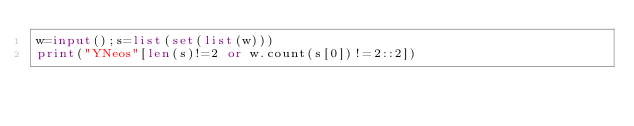Convert code to text. <code><loc_0><loc_0><loc_500><loc_500><_Python_>w=input();s=list(set(list(w)))
print("YNeos"[len(s)!=2 or w.count(s[0])!=2::2])</code> 